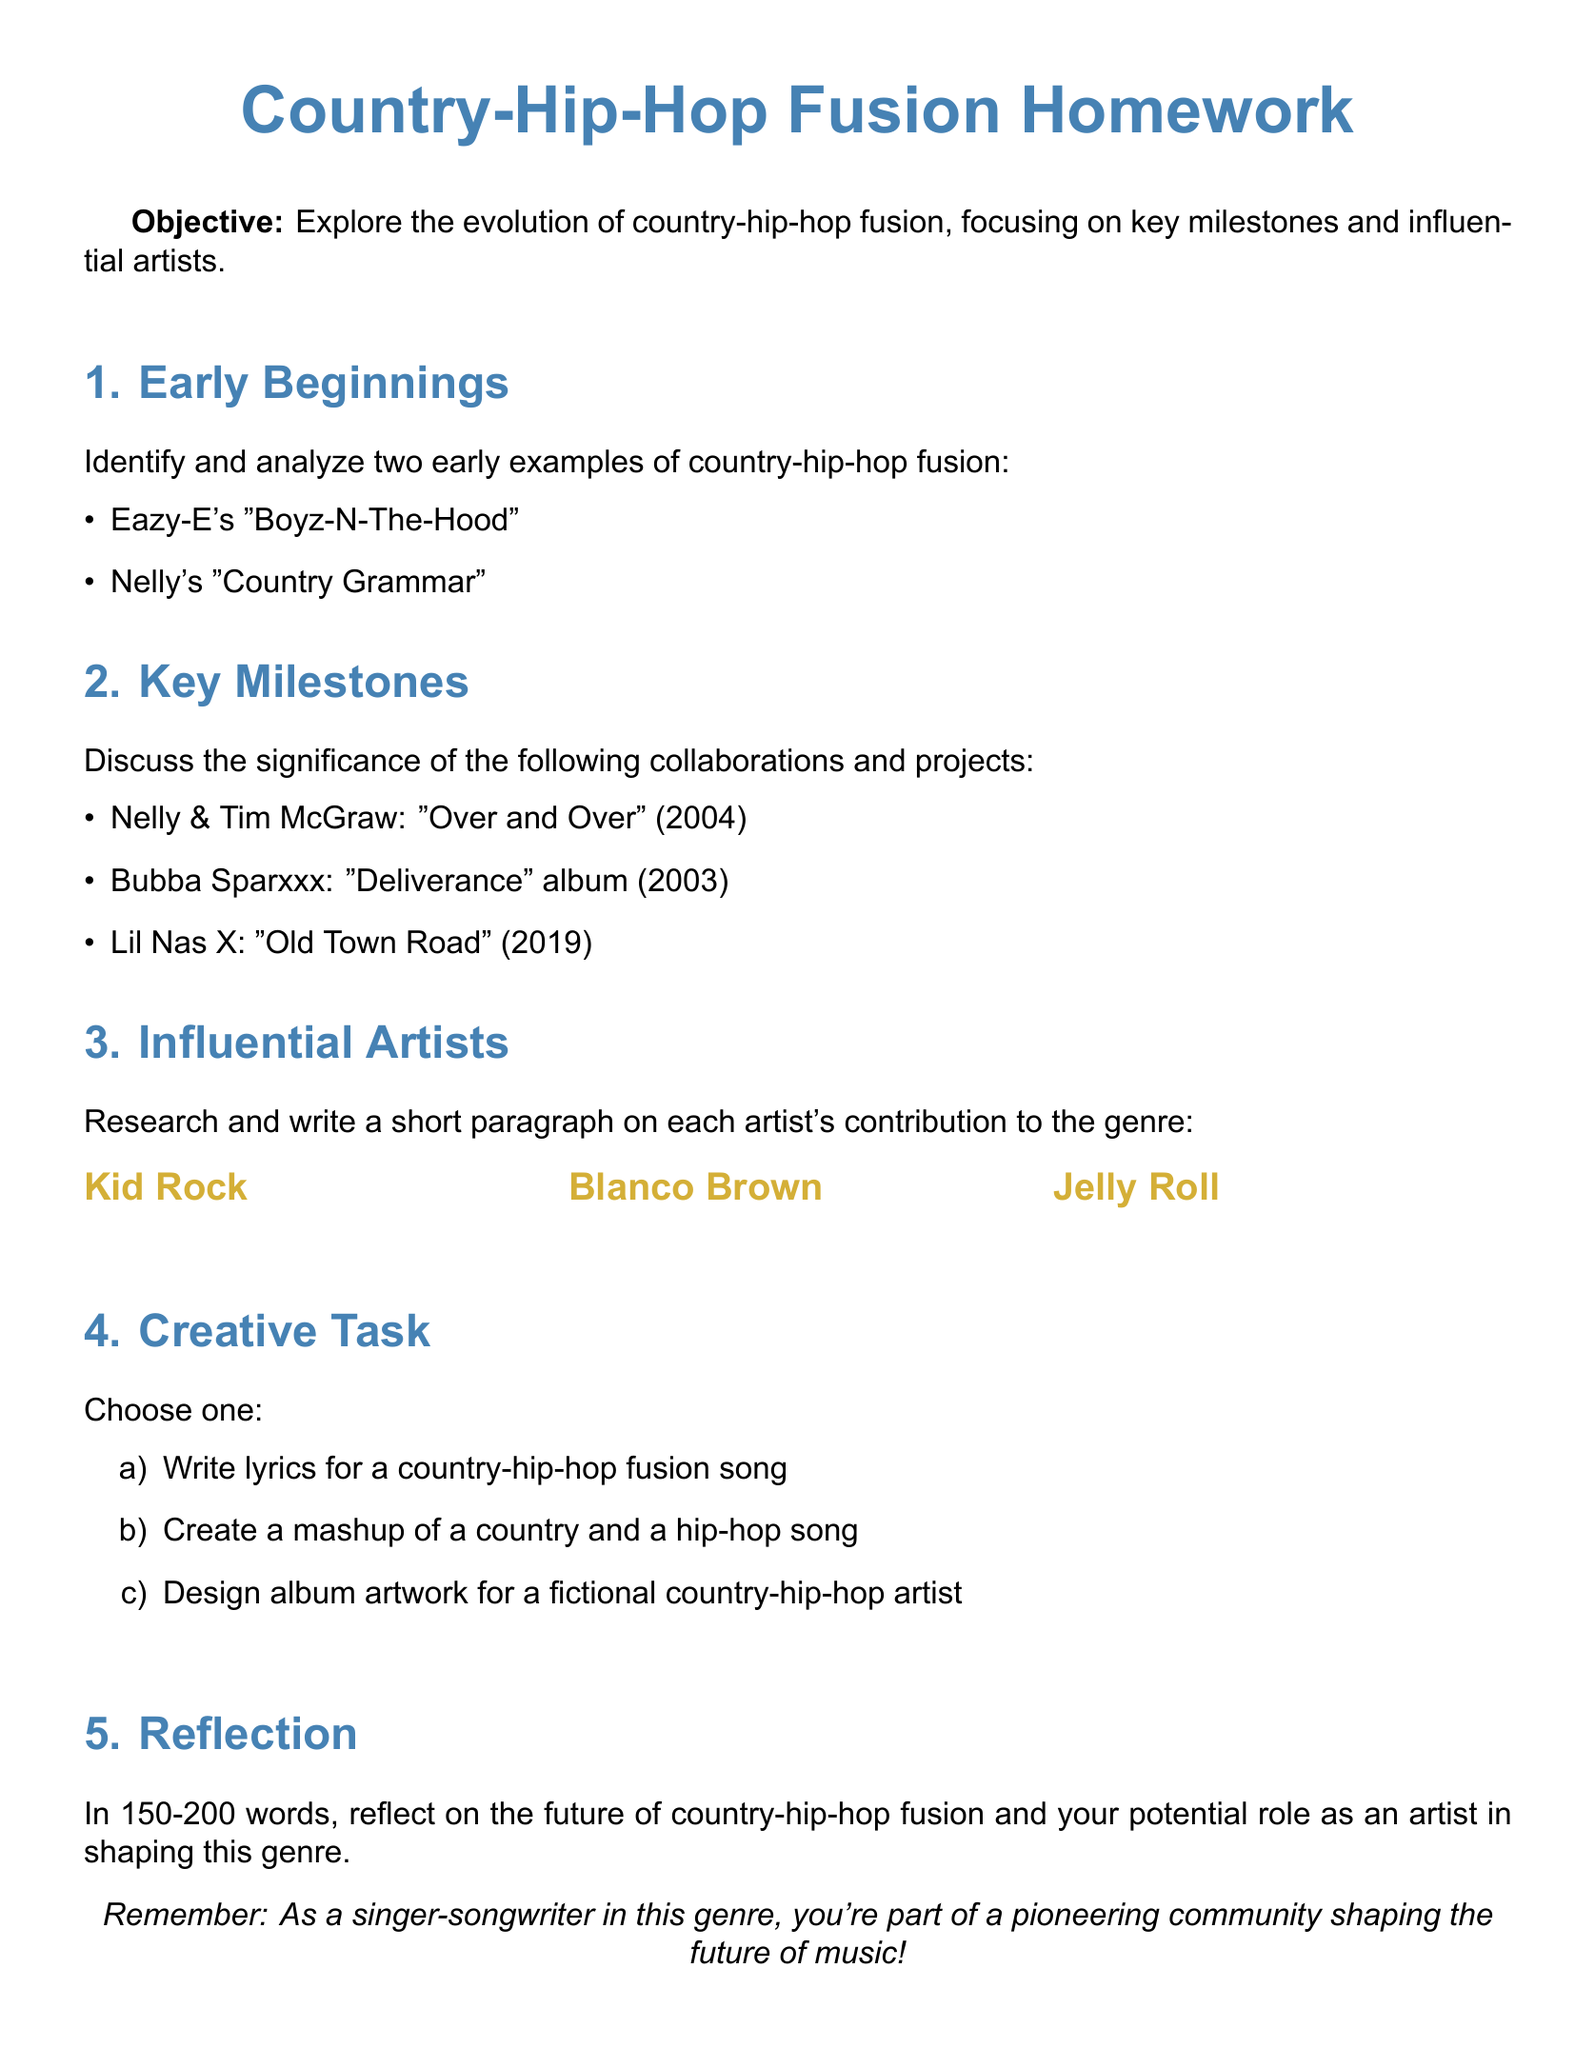What is the objective of the homework? The objective outlines the purpose of the assignment, which is to explore the evolution of country-hip-hop fusion.
Answer: Explore the evolution of country-hip-hop fusion Name one early example of country-hip-hop fusion. The document mentions two early examples; one can serve as a valid answer.
Answer: Eazy-E's "Boyz-N-The-Hood" Who collaborated with Nelly on the song "Over and Over"? The document specifies the collaboration between Nelly and another artist.
Answer: Tim McGraw What year was Bubba Sparxxx's "Deliverance" album released? The document lists the album with its release year, which is key information.
Answer: 2003 List one artist noted for their contribution to country-hip-hop fusion. The document names multiple artists, and any mentioned artist is acceptable as an answer.
Answer: Kid Rock What is the word limit for the reflection section? The document sets a range for the number of words required for the reflection.
Answer: 150-200 words Which two colors are used in the document? The document describes color schemes used for headings and sections.
Answer: Country blue and hip hop gold How many creative task options are presented? The document lists three options for a creative task, indicating the number available.
Answer: Three 